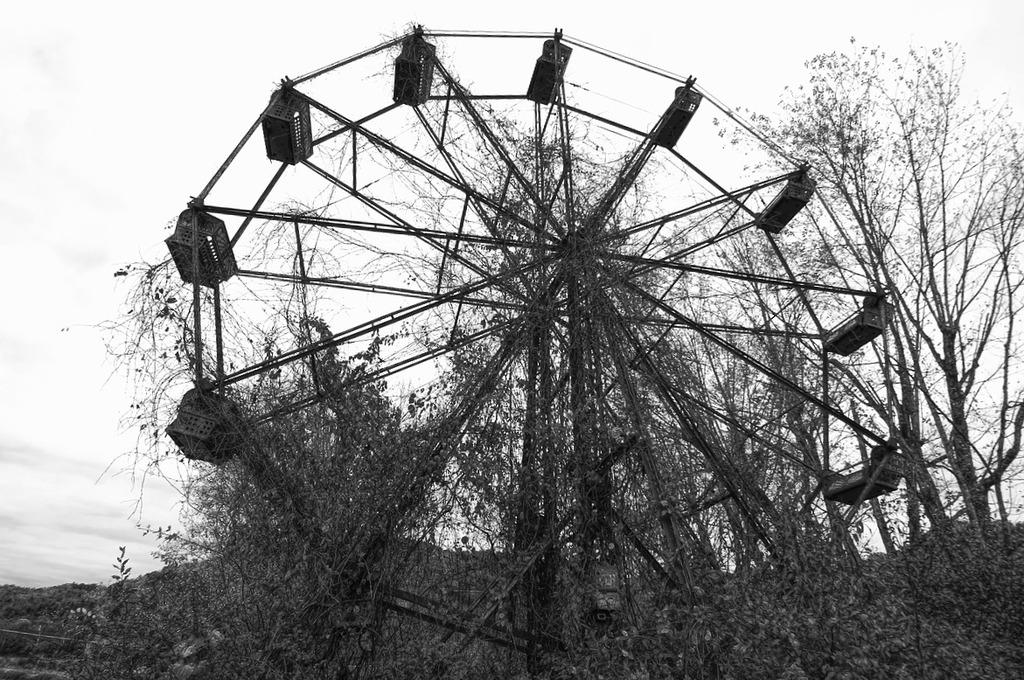What is the main structure in the image? There is a giant wheel in the image. What can be seen at the bottom of the image? There are trees and plants at the bottom of the image. What is visible at the top of the image? The sky is visible at the top of the image. What type of game is being played in the image? There is no game being played in the image; it features a giant wheel, trees and plants, and the sky. What kind of mint is growing in the plantation shown in the image? There is no plantation or mint present in the image. 